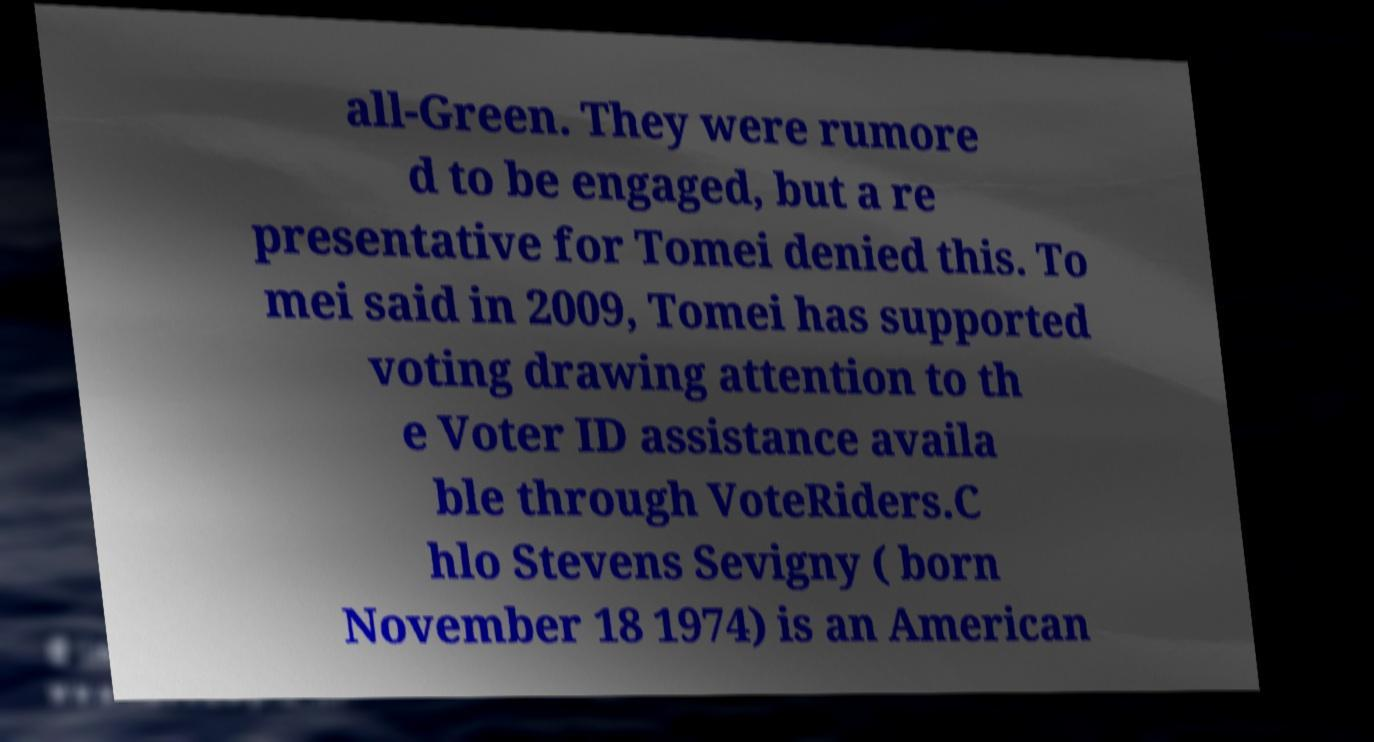Please read and relay the text visible in this image. What does it say? all-Green. They were rumore d to be engaged, but a re presentative for Tomei denied this. To mei said in 2009, Tomei has supported voting drawing attention to th e Voter ID assistance availa ble through VoteRiders.C hlo Stevens Sevigny ( born November 18 1974) is an American 